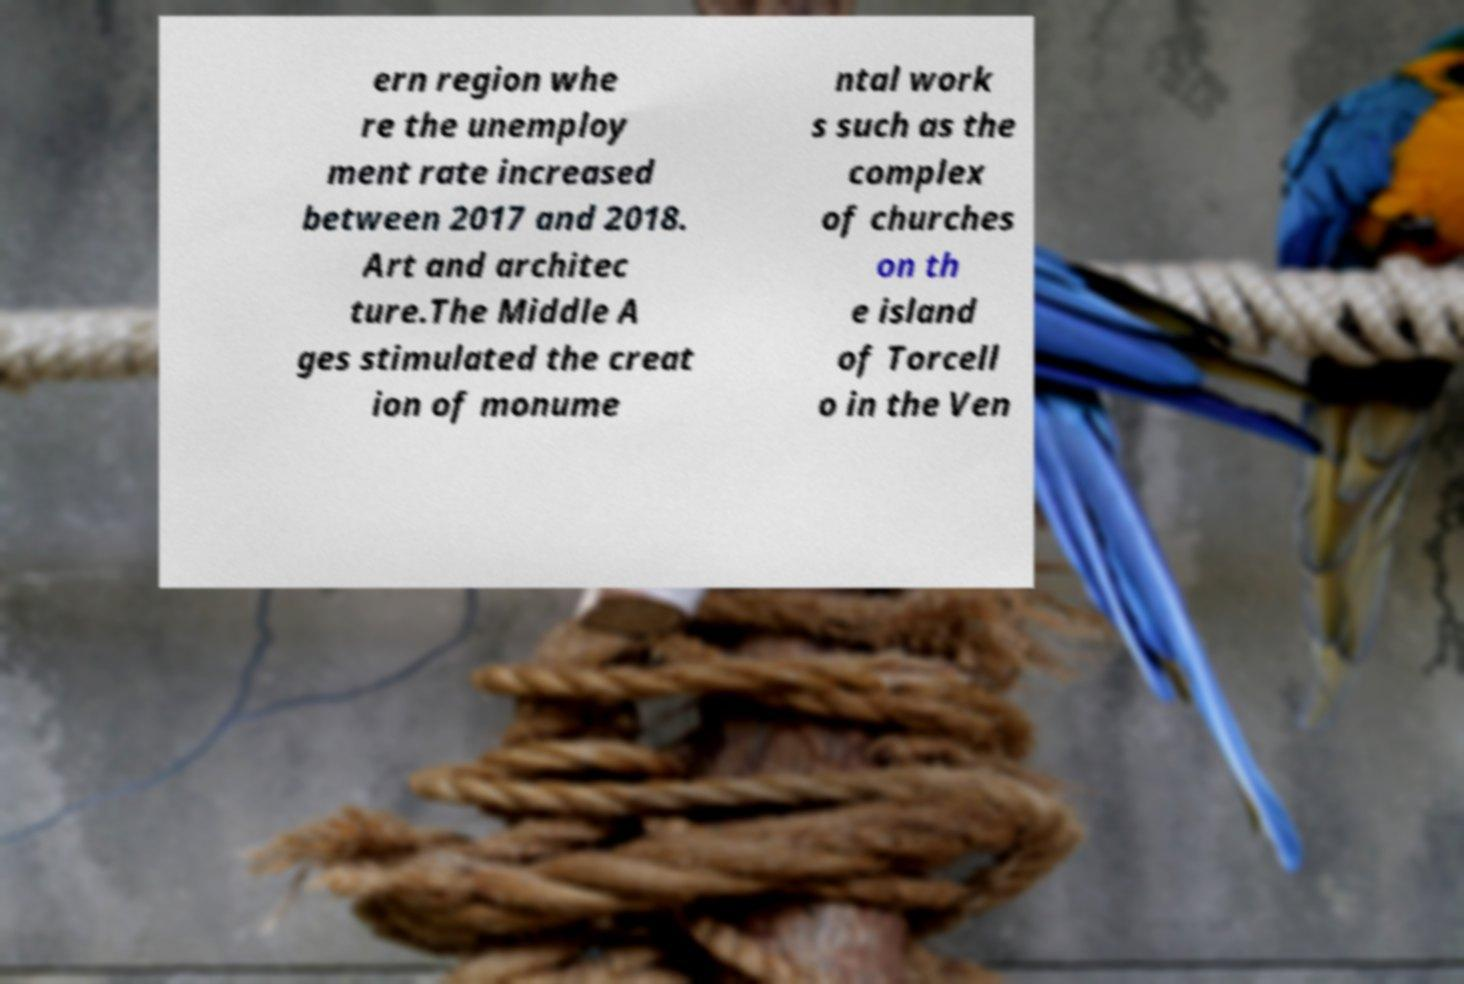Could you extract and type out the text from this image? ern region whe re the unemploy ment rate increased between 2017 and 2018. Art and architec ture.The Middle A ges stimulated the creat ion of monume ntal work s such as the complex of churches on th e island of Torcell o in the Ven 